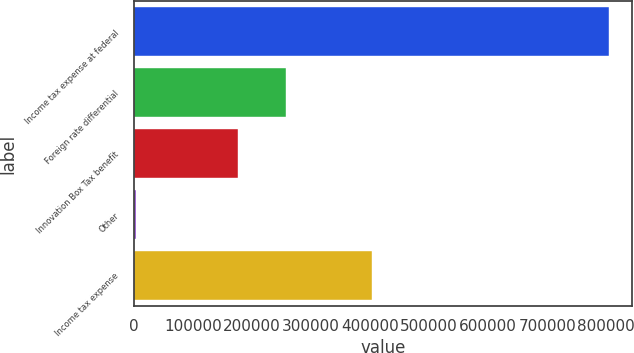Convert chart to OTSL. <chart><loc_0><loc_0><loc_500><loc_500><bar_chart><fcel>Income tax expense at federal<fcel>Foreign rate differential<fcel>Innovation Box Tax benefit<fcel>Other<fcel>Income tax expense<nl><fcel>803788<fcel>257170<fcel>177195<fcel>4040<fcel>403739<nl></chart> 